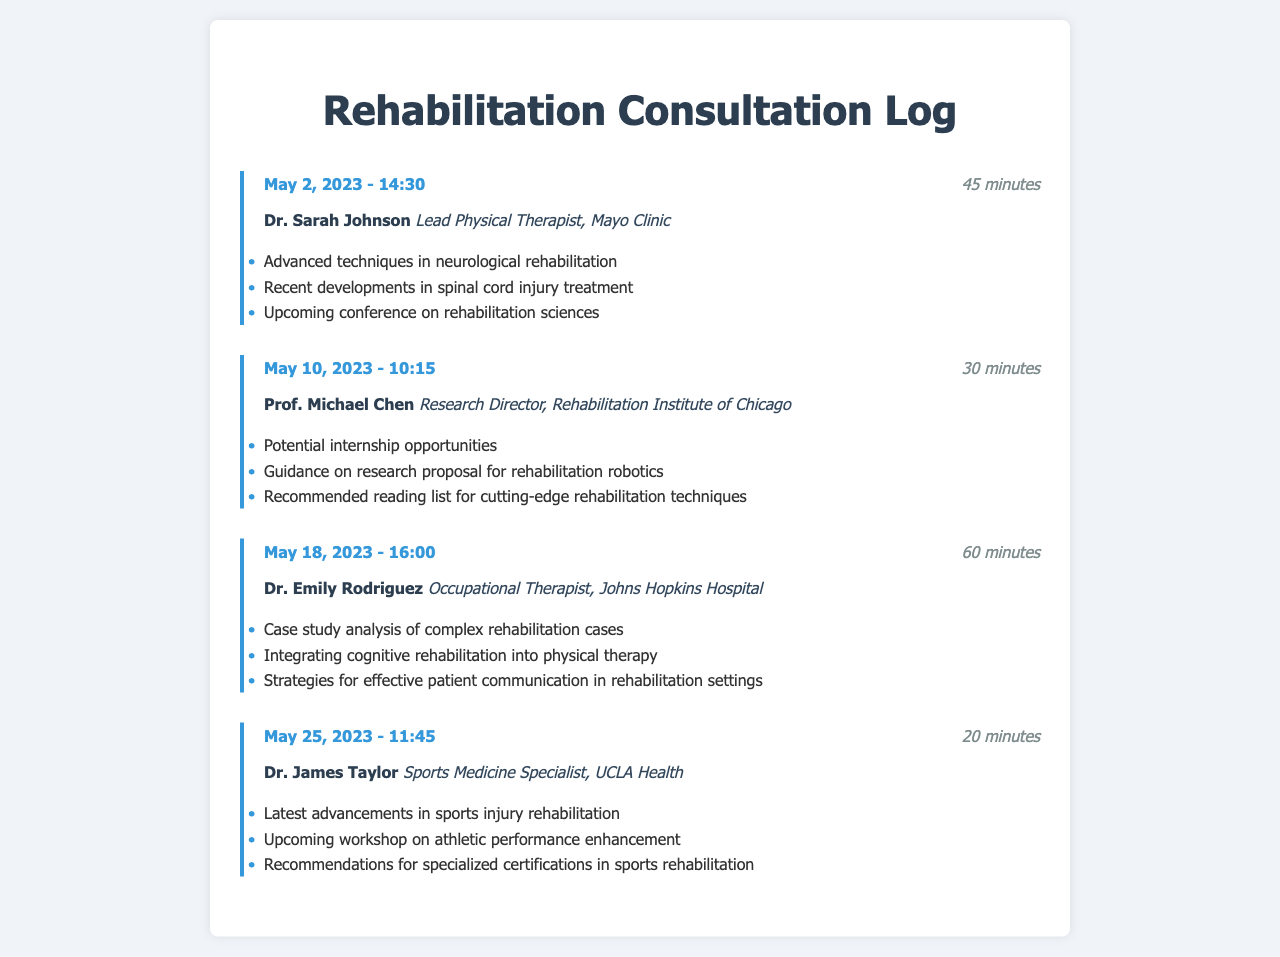What is the date of the first consultation? The date of the first consultation is found in the first call log, which is May 2, 2023.
Answer: May 2, 2023 Who is the contact for the longest call? The longest call in the logs is with Dr. Emily Rodriguez, which lasted 60 minutes.
Answer: Dr. Emily Rodriguez What is the duration of the call on May 25, 2023? The duration of the call on May 25, 2023, is listed under that specific call log as 20 minutes.
Answer: 20 minutes How many total consultations are recorded in the log? The number of consultations is found by counting the unique call logs present, which is four.
Answer: 4 What topics were discussed in the consultation with Dr. James Taylor? The topics discussed can be seen listed in the call log for Dr. James Taylor and include "Latest advancements in sports injury rehabilitation".
Answer: Latest advancements in sports injury rehabilitation What was one of the topics discussed during the consultation with Prof. Michael Chen? The topics discussed with Prof. Michael Chen include guidance on research proposal for rehabilitation robotics, which is listed in the call log.
Answer: Guidance on research proposal for rehabilitation robotics Which mentor is associated with the Mayo Clinic? The contact information for the mentor at the Mayo Clinic is found in the first call log, showing Dr. Sarah Johnson is associated with it.
Answer: Dr. Sarah Johnson What is the total duration of the calls recorded in this log? The total duration can be calculated as the sum of each individual call's duration in the log.
Answer: 155 minutes 